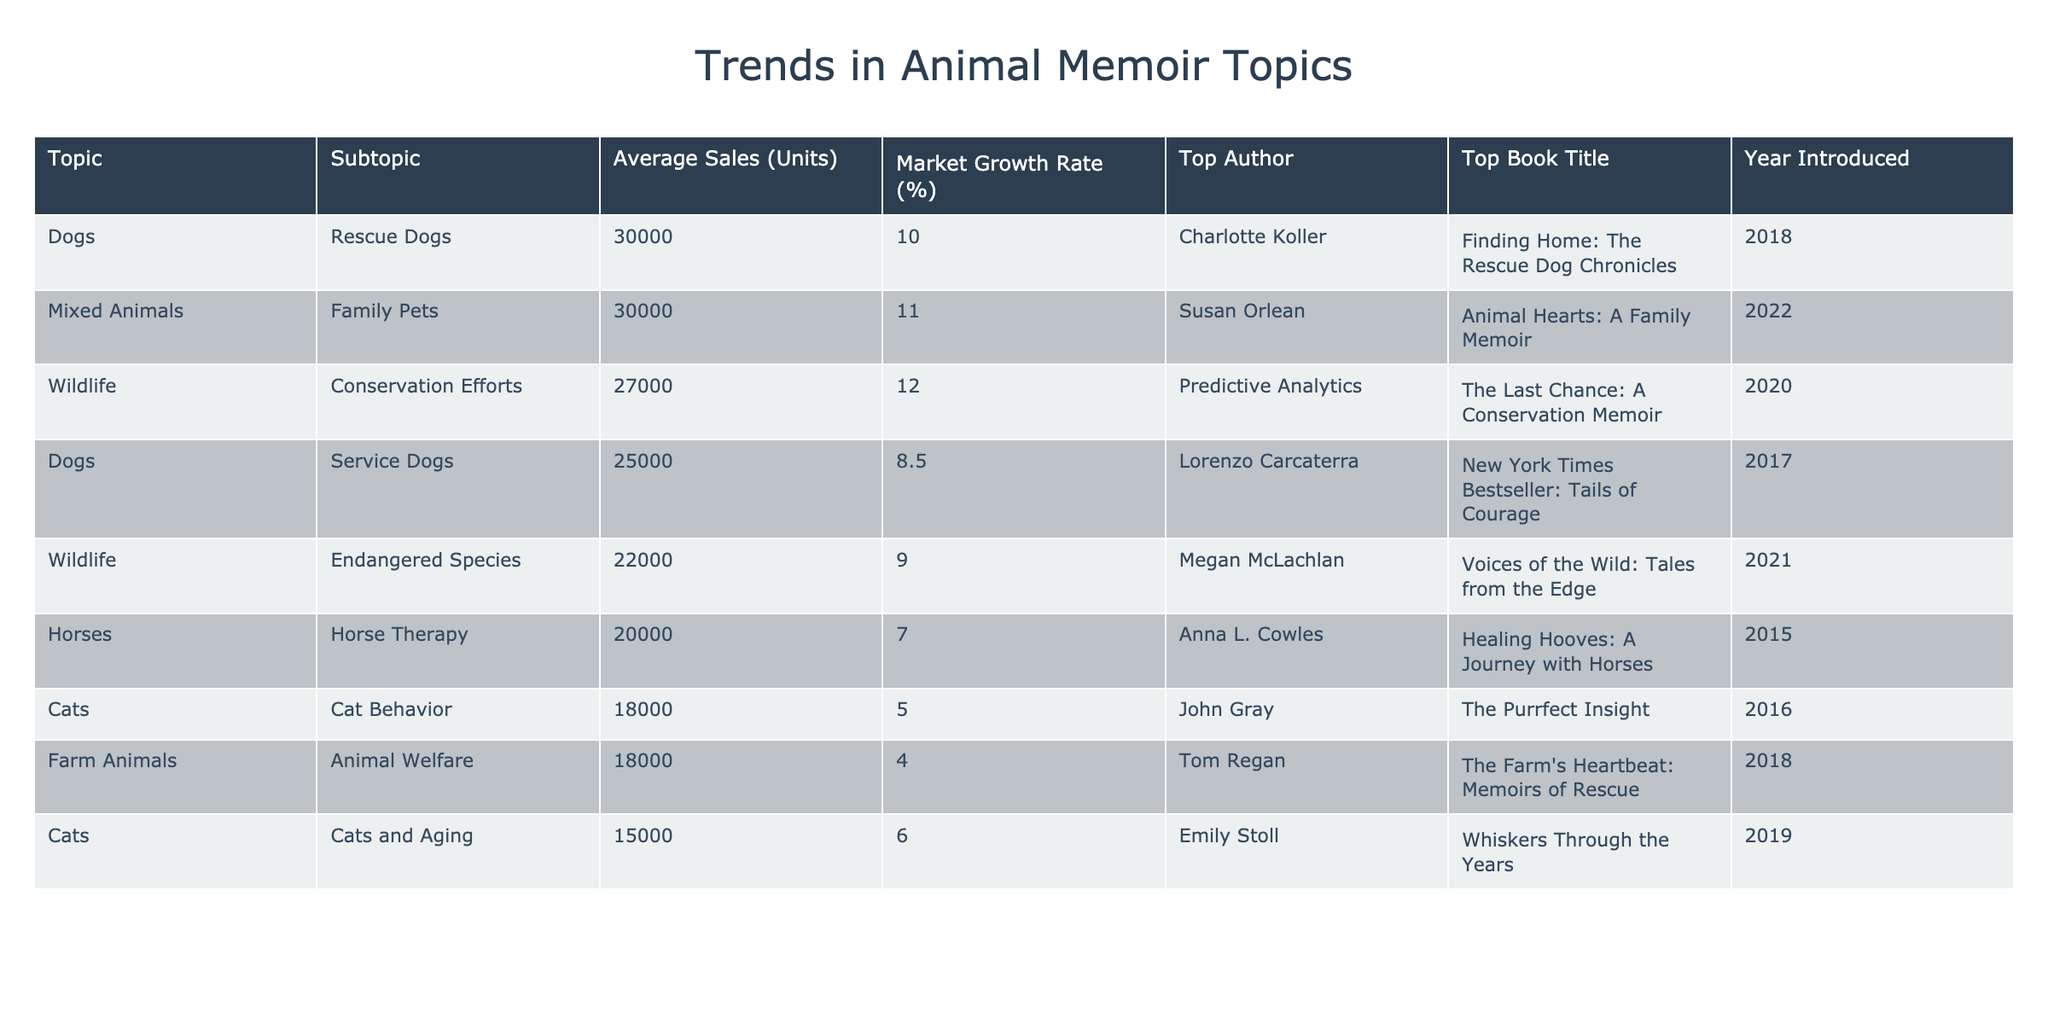What is the average sales for dog-related memoirs? To find the average sales for dog-related memoirs, we consider the two topics listed: Service Dogs (25,000 units) and Rescue Dogs (30,000 units). We sum these sales: 25,000 + 30,000 = 55,000. Then we divide by 2 (the number of topics): 55,000 / 2 = 27,500.
Answer: 27,500 Which wildlife memoir has the highest average sales? From the wildlife category, we have two memoirs: Endangered Species with 22,000 units and Conservation Efforts with 27,000 units. Comparing these, Conservation Efforts has the highest average sales at 27,000 units.
Answer: Conservation Efforts Is it true that cat behavior books have higher average sales than horse therapy books? Cat behavior books average 18,000 sales while horse therapy books average 20,000 sales. Since 18,000 is less than 20,000, this statement is false.
Answer: False Which top author has the highest average sales among the topics? The top authors with their average sales are: Lorenzo Carcaterra (25,000), Charlotte Koller (30,000), John Gray (18,000), Emily Stoll (15,000), Megan McLachlan (22,000), Predictive Analytics (27,000), Anna L. Cowles (20,000), Tom Regan (18,000), Susan Orlean (30,000). Charlotte Koller and Susan Orlean both stand out with 30,000 units.
Answer: Charlotte Koller and Susan Orlean What is the growth rate of mixed animals compared to cats? The growth rate for mixed animals is 11% and for cats is 5%. To find the difference: 11 - 5 = 6%. This means mixed animals have a growth rate of 6% higher than cats.
Answer: 6% higher How many topics have an average sales figure below 20,000 units? We review the sales figures: Cat Behavior (18,000), Cats and Aging (15,000), Farm Animals (18,000) are below 20,000. Hence, there are 3 topics with sales below this threshold.
Answer: 3 Which topic has the lowest average sales? Looking through the table, Cat Behavior has the lowest average sales at 18,000 units compared to others.
Answer: Cat Behavior What is the total average sales of all horse-related and farm animal-related memoirs? There are two horse-related books (Horse Therapy at 20,000) and one farm animal-related book (Animal Welfare at 18,000). The total sales is 20,000 + 18,000 = 38,000. To find the average, we divide by 3: 38,000 / 3 = 12,666.67.
Answer: 12,666.67 